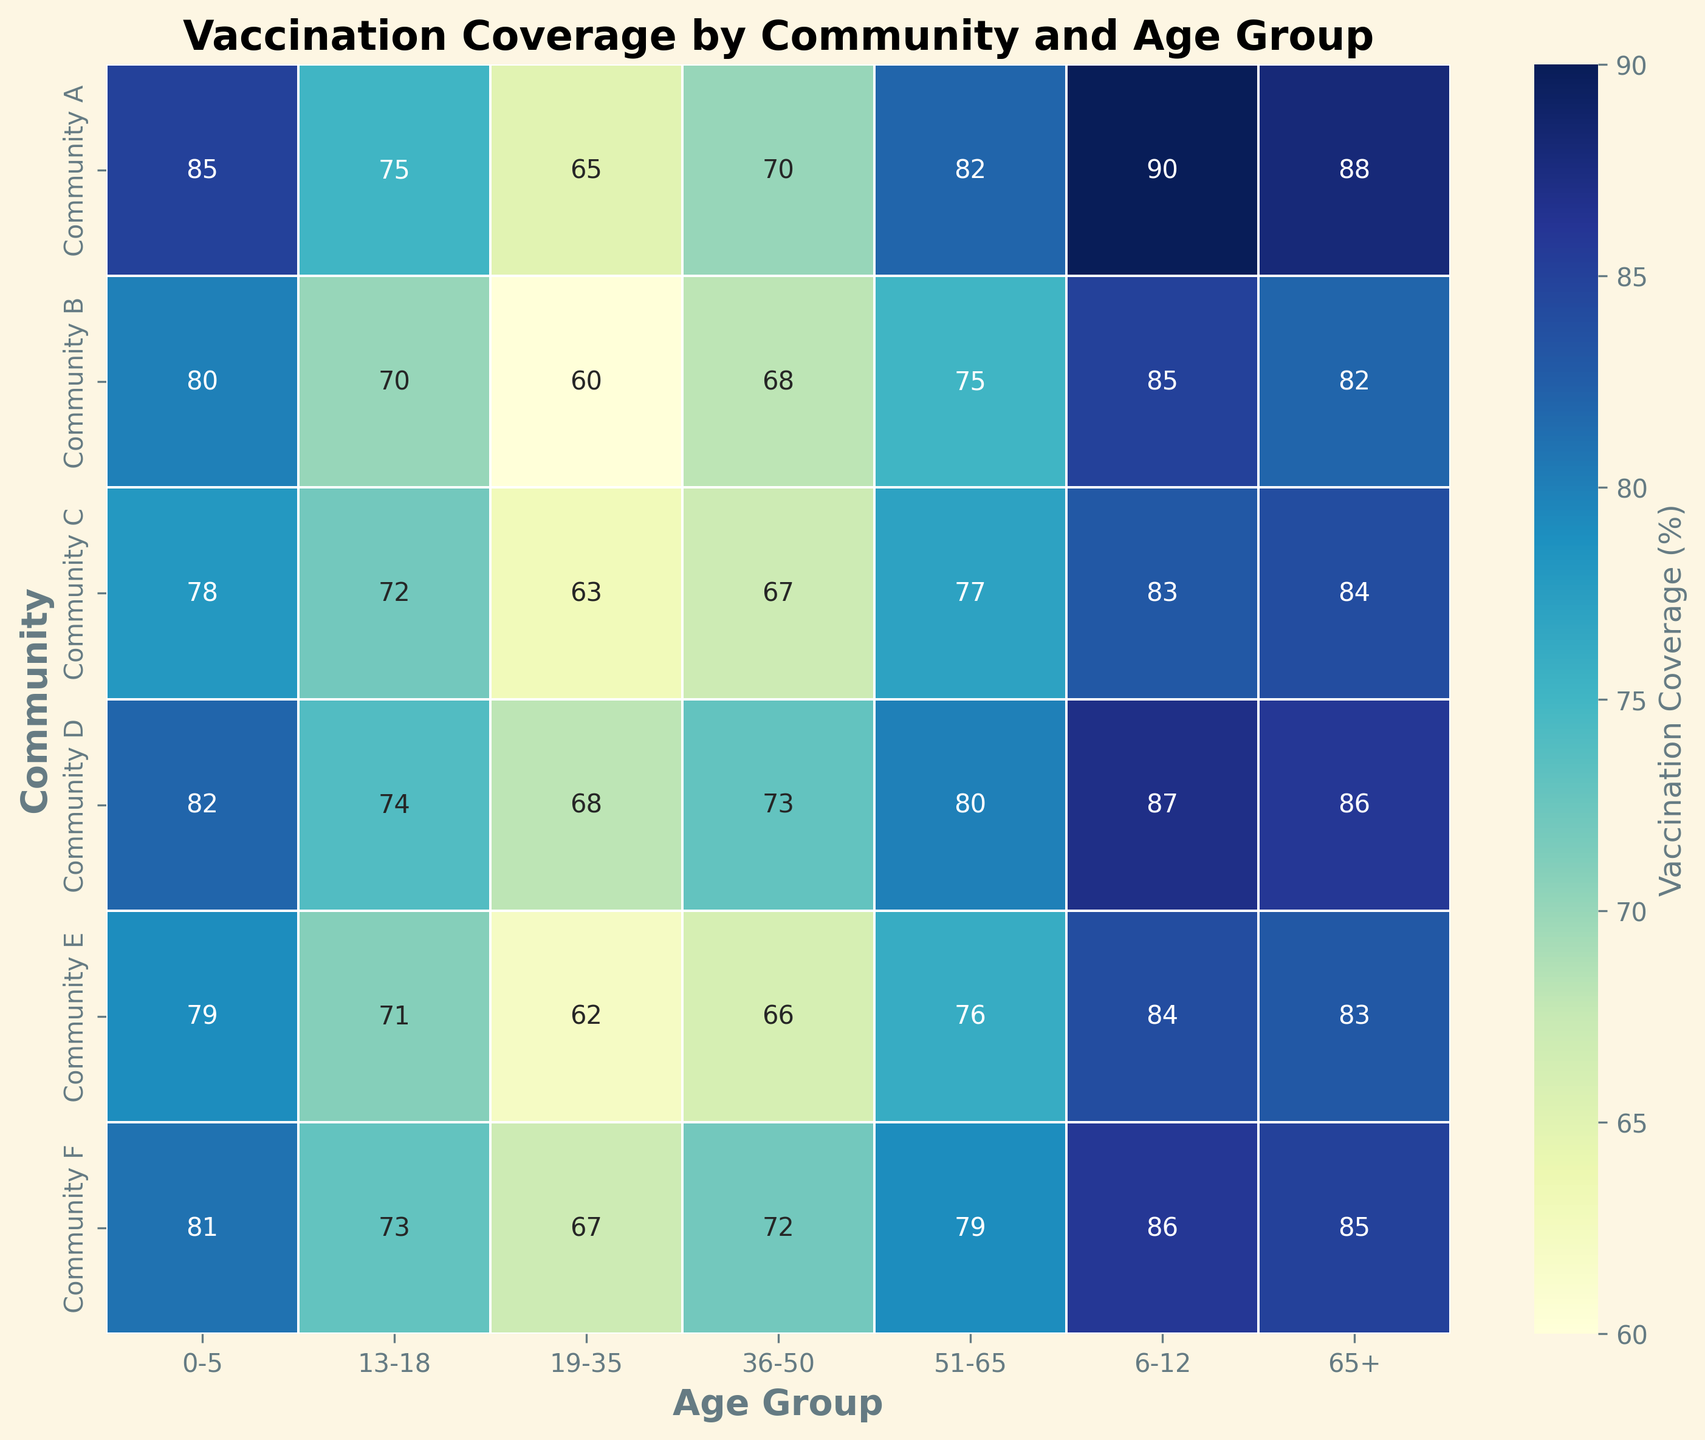Which community has the lowest vaccination coverage for the 19-35 age group? Compare the values for the 19-35 age group across all the communities. Community B has the lowest vaccination coverage at 60%.
Answer: Community B Which age group in Community A has the highest vaccination coverage? Look at the annotated values for Community A across all age groups. The 6-12 age group has the highest vaccination coverage at 90%.
Answer: 6-12 What is the overall trend of vaccination coverage with increasing age in Community D? Observe the vaccination coverage values for Community D across the age groups from 0-5 to 65+. The coverage appears to be relatively high for younger age groups, declines through the middle age groups (19-35 and 36-50), and then increases again in the older age groups.
Answer: Peaks in early and late stages, dips in mid-stages Which age group has the smallest range of vaccination coverage across all communities? Compare the range (difference between the highest and lowest values) of vaccination coverage for each age group across all communities. The 0-5 age group has the smallest range, varying between 78 and 85.
Answer: 0-5 What is the difference in vaccination coverage between the 13-18 age group and the 19-35 age group in Community F? Look at the values for the 13-18 and 19-35 age groups in Community F. The difference is 73 - 67 = 6.
Answer: 6 Which community shows the most consistent vaccination coverage across all age groups? Consistency can be measured by the smallest variation (range) between the highest and lowest vaccination coverage values. Community F has coverage values ranging from 67 to 86.
Answer: Community F What is the average vaccination coverage for the age group 36-50 across all communities? Sum the vaccination coverage values for the 36-50 age group across all communities and divide by the number of communities. (70 + 68 + 67 + 73 + 66 + 72) / 6 = 416 / 6 ≈ 69.33.
Answer: 69.33 Which age group is most affected by lack of awareness in Community C? Look for the age group with "Lack of Awareness" as the common barrier in Community C. The 19-35 age group has vaccination coverage of 63 and faces lack of awareness.
Answer: 19-35 Is there a noticeable color pattern that indicates a specific trend in the heatmap? Observe the heatmap colors. Communities generally have higher vaccination coverage (yellow/green colors) for younger and older age groups, with a dip (more blueish) in the middle age groups.
Answer: High coverage in young and old, lower in middle What is the combined difference in vaccination coverage for the age groups 0-5 and 65+ between Community C and Community A? Calculate the difference for each age group and add the results. (85 - 78) + (88 - 84) = 7 + 4 = 11.
Answer: 11 